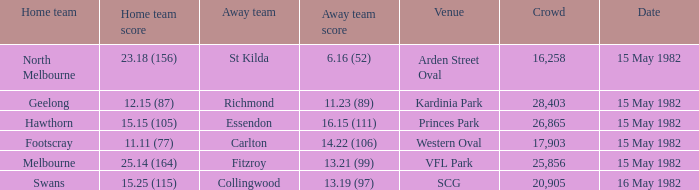What did the away team score when playing Footscray? 14.22 (106). 